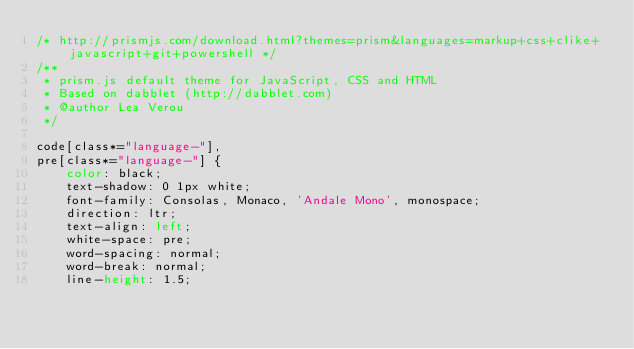<code> <loc_0><loc_0><loc_500><loc_500><_CSS_>/* http://prismjs.com/download.html?themes=prism&languages=markup+css+clike+javascript+git+powershell */
/**
 * prism.js default theme for JavaScript, CSS and HTML
 * Based on dabblet (http://dabblet.com)
 * @author Lea Verou
 */

code[class*="language-"],
pre[class*="language-"] {
	color: black;
	text-shadow: 0 1px white;
	font-family: Consolas, Monaco, 'Andale Mono', monospace;
	direction: ltr;
	text-align: left;
	white-space: pre;
	word-spacing: normal;
	word-break: normal;
	line-height: 1.5;
</code> 